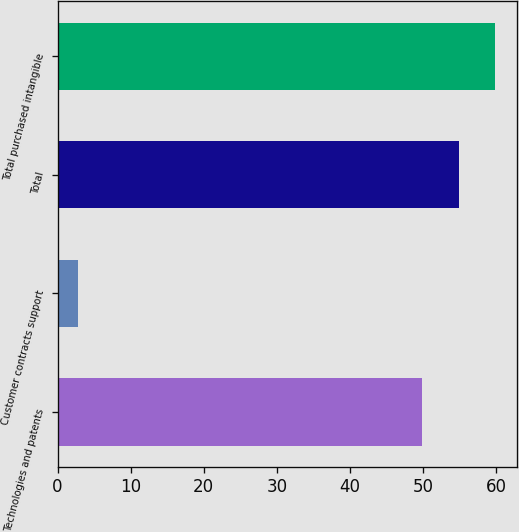<chart> <loc_0><loc_0><loc_500><loc_500><bar_chart><fcel>Technologies and patents<fcel>Customer contracts support<fcel>Total<fcel>Total purchased intangible<nl><fcel>49.9<fcel>2.8<fcel>54.89<fcel>59.88<nl></chart> 